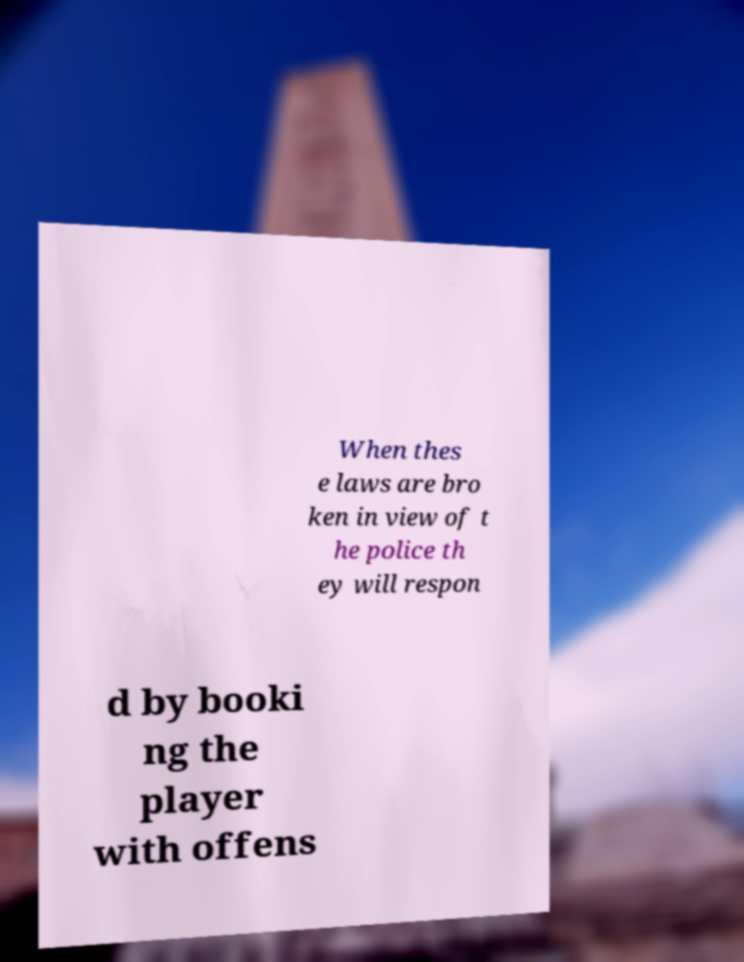Please identify and transcribe the text found in this image. When thes e laws are bro ken in view of t he police th ey will respon d by booki ng the player with offens 